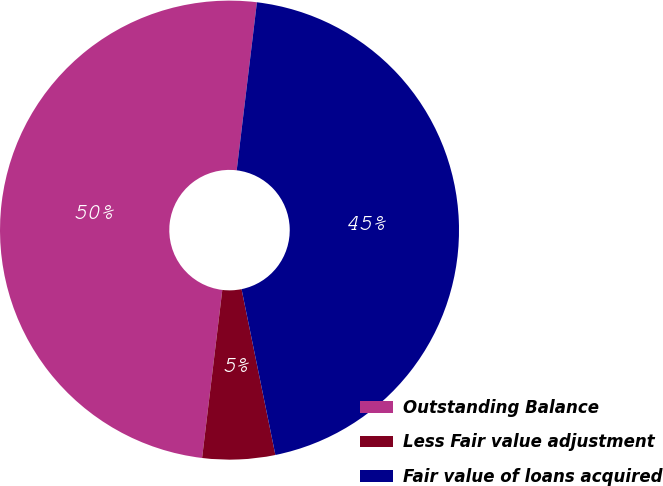Convert chart to OTSL. <chart><loc_0><loc_0><loc_500><loc_500><pie_chart><fcel>Outstanding Balance<fcel>Less Fair value adjustment<fcel>Fair value of loans acquired<nl><fcel>50.0%<fcel>5.11%<fcel>44.89%<nl></chart> 